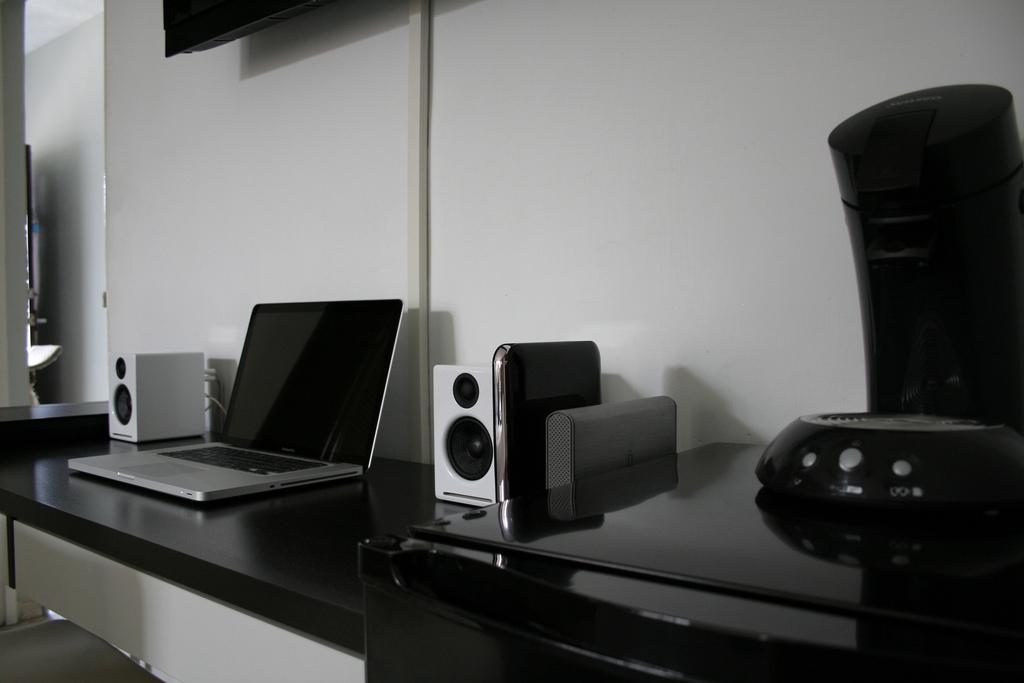How many white audio computer speakers are on the desk?
Give a very brief answer. 2. How many circles are in the photo?
Give a very brief answer. 8. How many buttons does the coffee maker have?
Give a very brief answer. 3. How many plugs are showing on the left hand speaker?
Give a very brief answer. 3. How many speakers on the desk?
Give a very brief answer. 2. How many holes does a speaker have?
Give a very brief answer. 2. How many laptops are on desk?
Give a very brief answer. 2. 